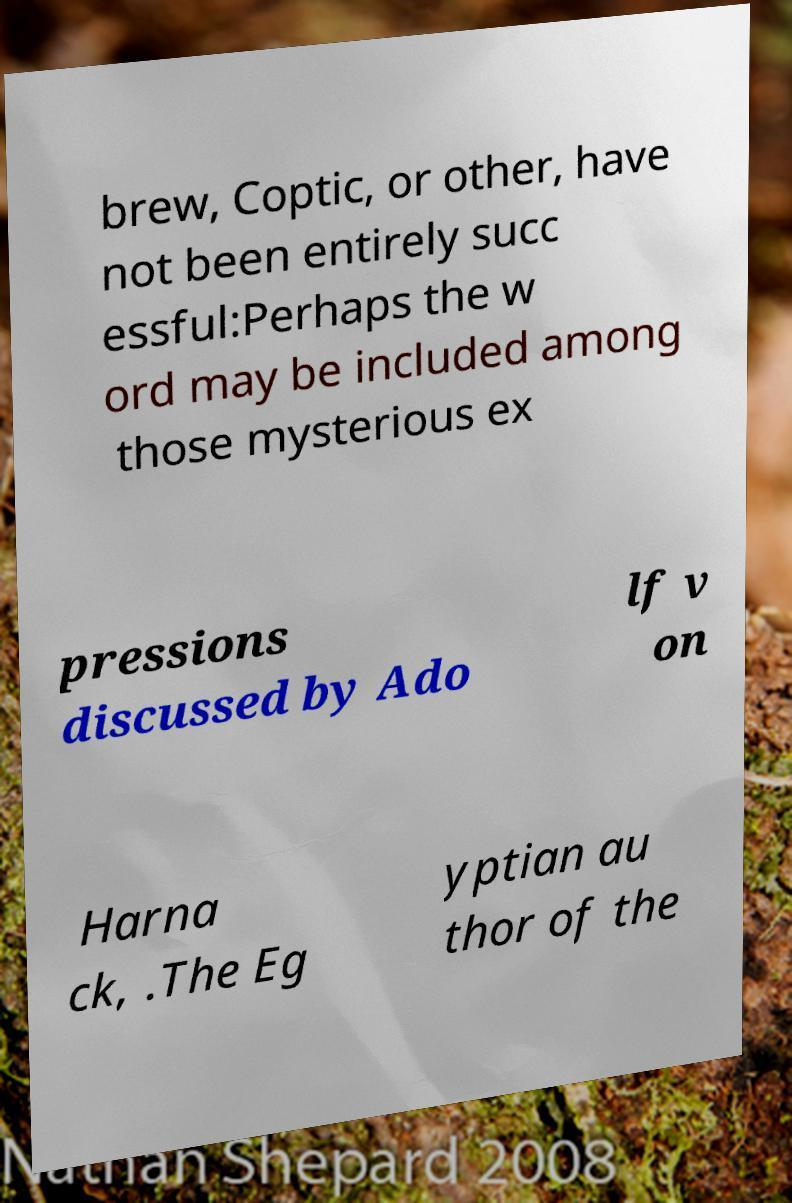I need the written content from this picture converted into text. Can you do that? brew, Coptic, or other, have not been entirely succ essful:Perhaps the w ord may be included among those mysterious ex pressions discussed by Ado lf v on Harna ck, .The Eg yptian au thor of the 